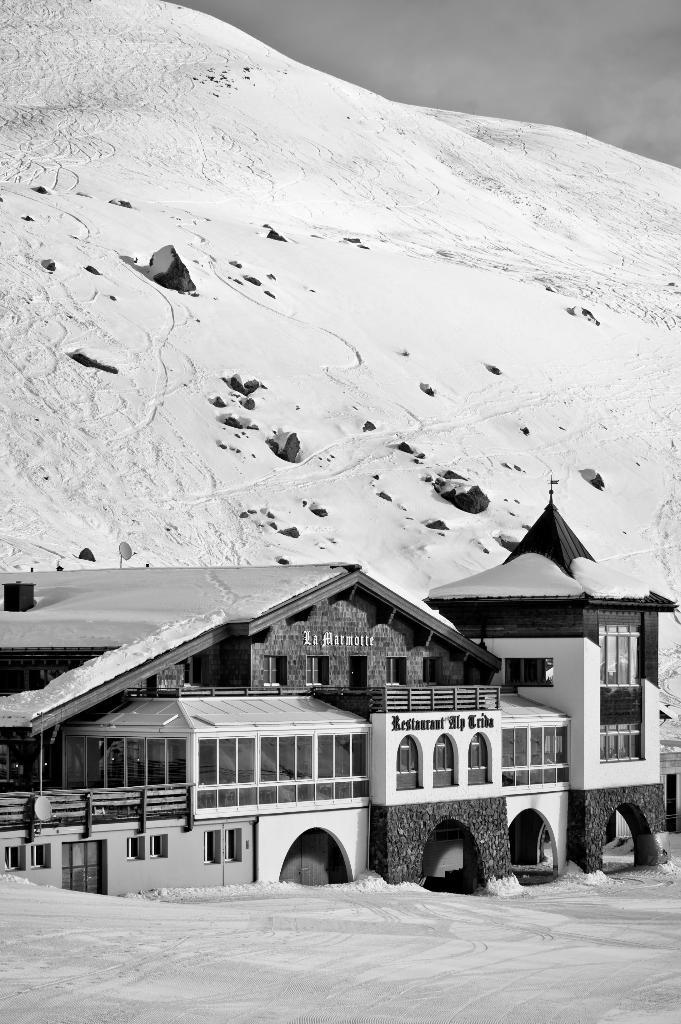What is the color scheme of the image? The image is black and white. What can be seen on the building in the image? There are name boards on the building in the image. What is visible behind the building? There is a snowy hill behind the building. How would you describe the sky in the image? The sky is cloudy in the image. What type of truck can be seen driving through the duck pond in the image? There is no truck or duck pond present in the image; it features a building with name boards, a snowy hill, and a cloudy sky. 